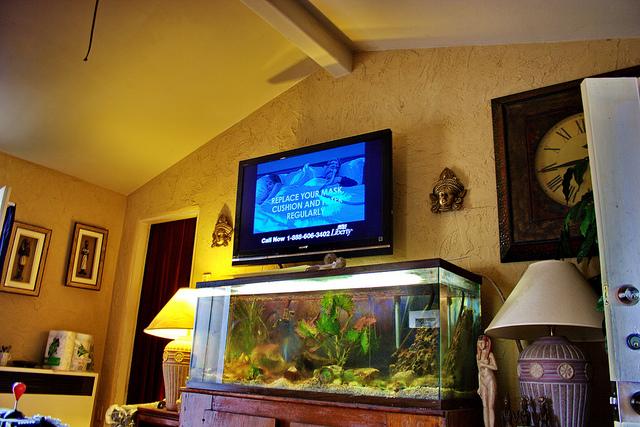What is the finish on the wall behind the TV?
Keep it brief. Stucco. Is this a TV screen?
Be succinct. Yes. What color is the wall?
Short answer required. Tan. How many televisions are on?
Write a very short answer. 1. Is there water in the tank?
Quick response, please. Yes. What is the large object under the TV?
Keep it brief. Fish tank. What time does the clock say?
Be succinct. 3:45. 